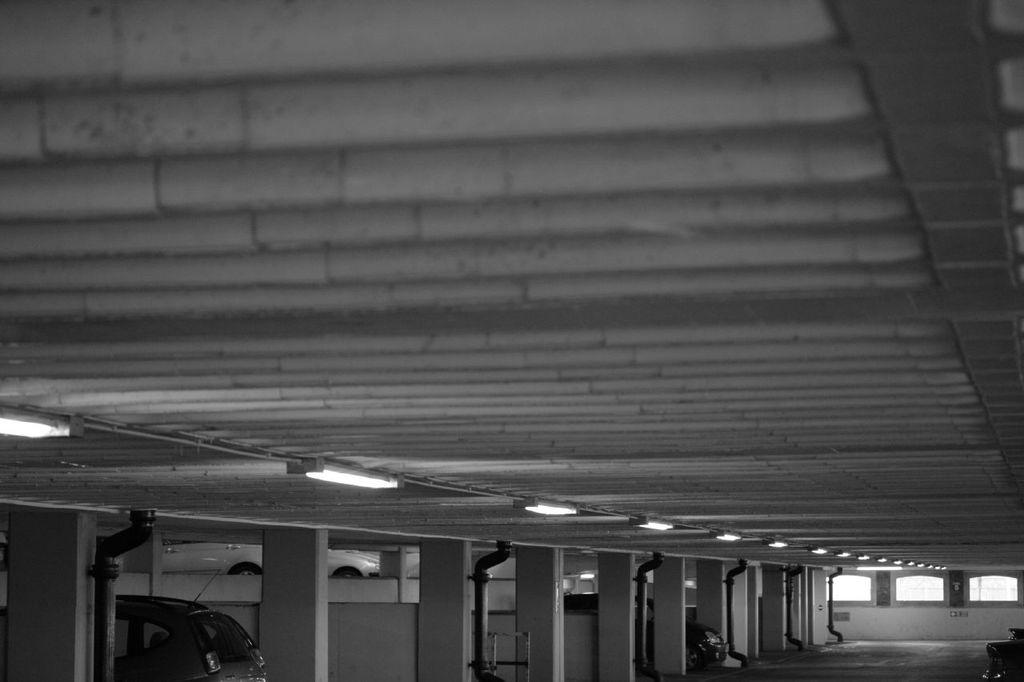What structures can be seen in the foreground of the image? There are pillars and pipes in the foreground of the image. What else is present in the foreground of the image? There are vehicles and the floor visible in the foreground of the image. Can you describe the lighting in the image? There are lights on the inside roof of the image. What word is written on the side of the tramp in the image? There is no tramp present in the image, so no word can be read on its side. How does the heat affect the vehicles in the image? There is no mention of heat in the image, and therefore its effect on the vehicles cannot be determined. 